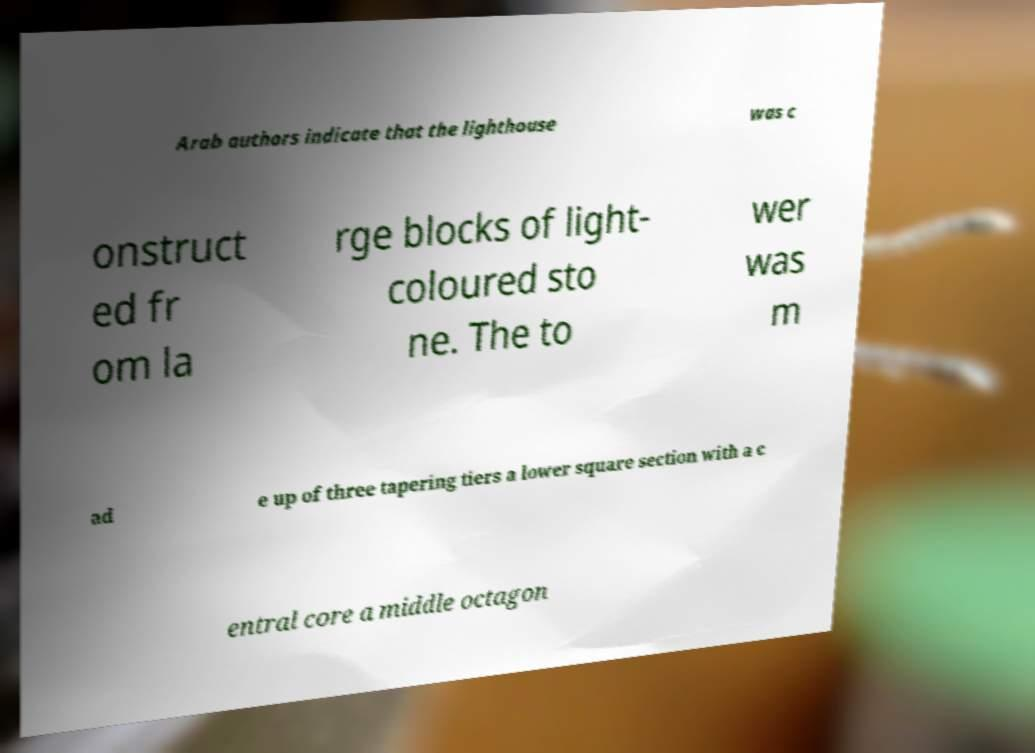Could you extract and type out the text from this image? Arab authors indicate that the lighthouse was c onstruct ed fr om la rge blocks of light- coloured sto ne. The to wer was m ad e up of three tapering tiers a lower square section with a c entral core a middle octagon 